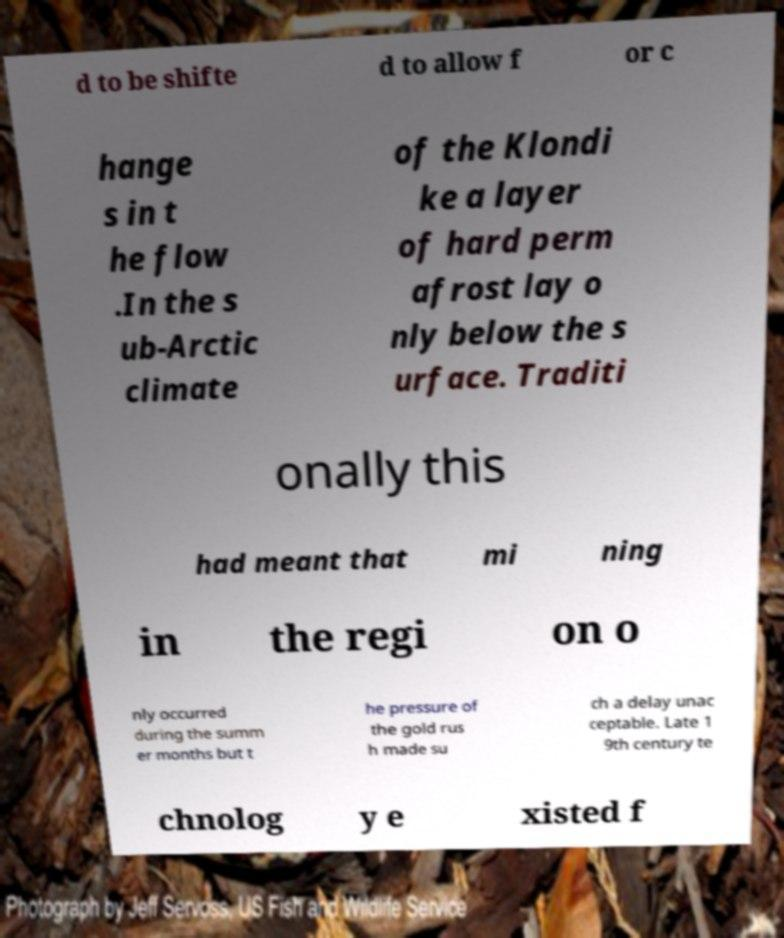Please read and relay the text visible in this image. What does it say? d to be shifte d to allow f or c hange s in t he flow .In the s ub-Arctic climate of the Klondi ke a layer of hard perm afrost lay o nly below the s urface. Traditi onally this had meant that mi ning in the regi on o nly occurred during the summ er months but t he pressure of the gold rus h made su ch a delay unac ceptable. Late 1 9th century te chnolog y e xisted f 